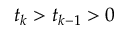<formula> <loc_0><loc_0><loc_500><loc_500>t _ { k } > t _ { k - 1 } > 0</formula> 